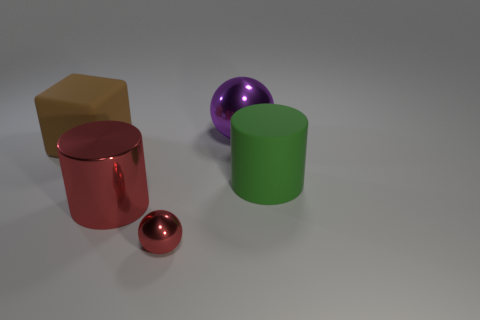Add 4 brown matte objects. How many objects exist? 9 Subtract all cylinders. How many objects are left? 3 Subtract 0 cyan balls. How many objects are left? 5 Subtract all matte cylinders. Subtract all red shiny spheres. How many objects are left? 3 Add 1 large green matte cylinders. How many large green matte cylinders are left? 2 Add 3 small red cylinders. How many small red cylinders exist? 3 